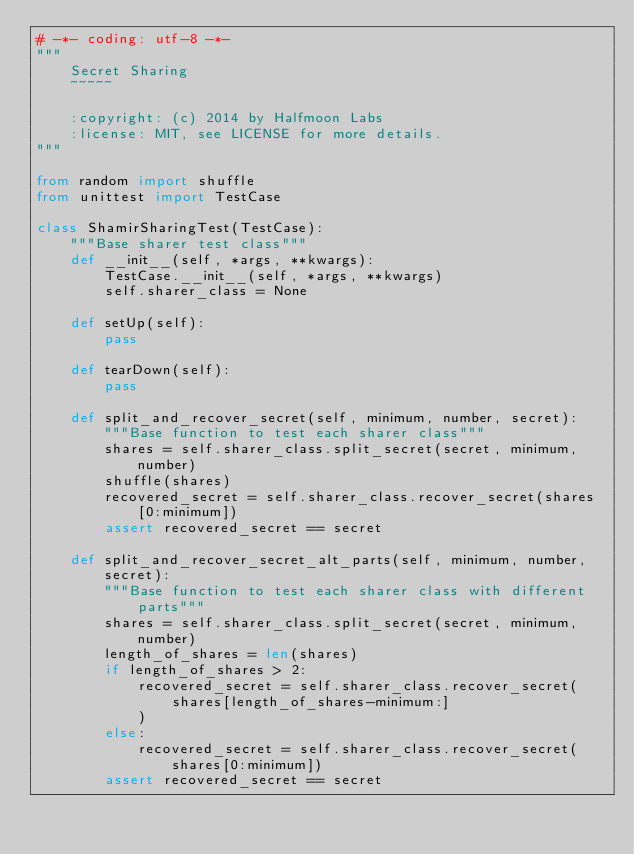Convert code to text. <code><loc_0><loc_0><loc_500><loc_500><_Python_># -*- coding: utf-8 -*-
"""
    Secret Sharing
    ~~~~~

    :copyright: (c) 2014 by Halfmoon Labs
    :license: MIT, see LICENSE for more details.
"""

from random import shuffle
from unittest import TestCase

class ShamirSharingTest(TestCase):
    """Base sharer test class"""
    def __init__(self, *args, **kwargs):
        TestCase.__init__(self, *args, **kwargs)
        self.sharer_class = None

    def setUp(self):
        pass

    def tearDown(self):
        pass

    def split_and_recover_secret(self, minimum, number, secret):
        """Base function to test each sharer class"""
        shares = self.sharer_class.split_secret(secret, minimum, number)
        shuffle(shares)
        recovered_secret = self.sharer_class.recover_secret(shares[0:minimum])
        assert recovered_secret == secret

    def split_and_recover_secret_alt_parts(self, minimum, number, secret):
        """Base function to test each sharer class with different parts"""
        shares = self.sharer_class.split_secret(secret, minimum, number)
        length_of_shares = len(shares)
        if length_of_shares > 2:
            recovered_secret = self.sharer_class.recover_secret(
                shares[length_of_shares-minimum:]
            )
        else:
            recovered_secret = self.sharer_class.recover_secret(shares[0:minimum])
        assert recovered_secret == secret
</code> 